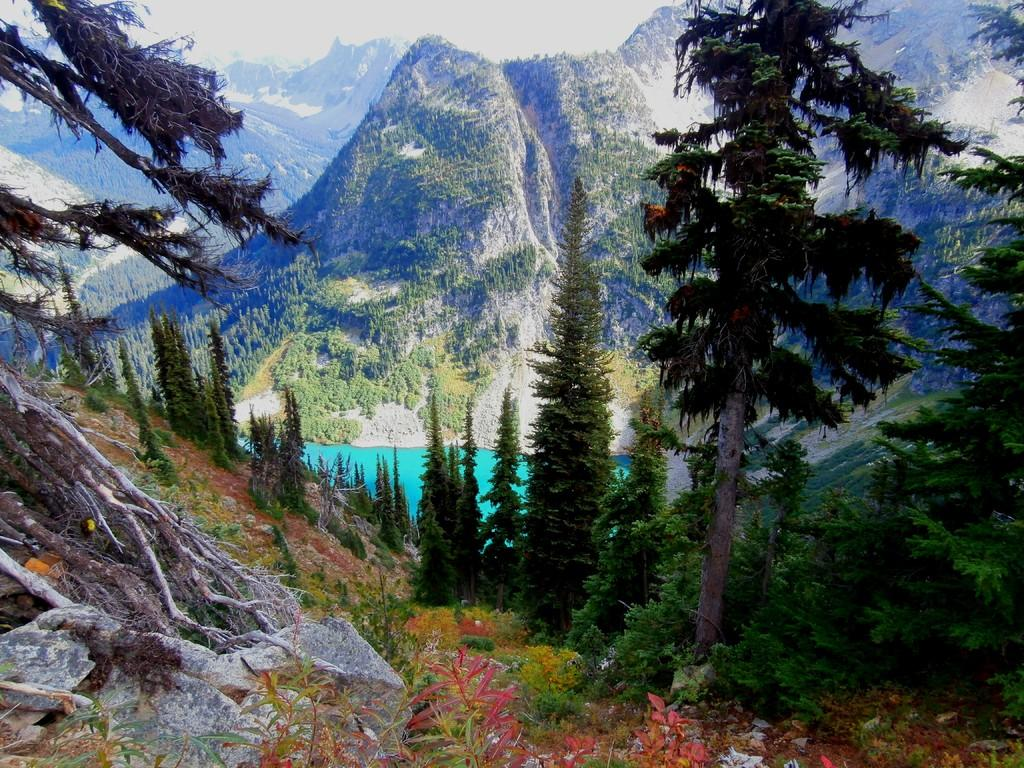What type of natural features can be seen in the image? There are trees, hills, and rocks visible in the image. What other types of vegetation are present in the image? There are plants in the image. Is there any water visible in the image? Yes, there is water visible in the image. What type of insect can be seen crawling on the notebook in the image? There is no notebook or insect present in the image. 